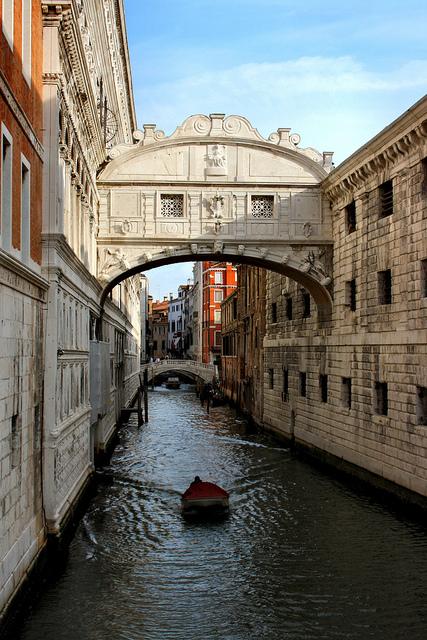Based on the size of the wake what is the approximate speed of the boat?
Write a very short answer. 5 mph. What city is this taken in?
Concise answer only. Venice. Are there any water skiers in the picture?
Quick response, please. No. 